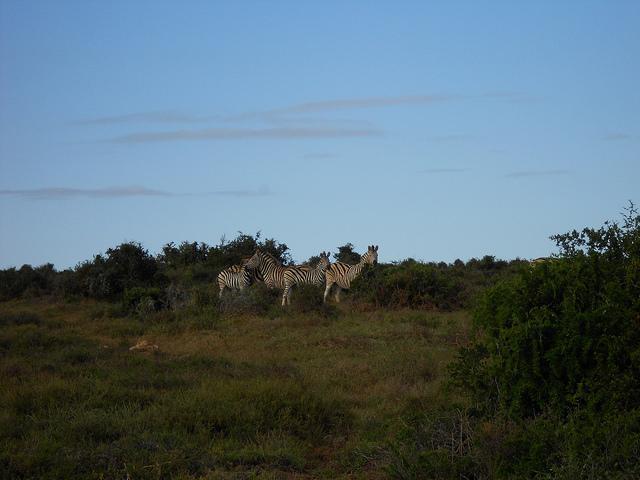How many types of animals are there?
Give a very brief answer. 1. How many roads are there?
Give a very brief answer. 0. How many cars are shown?
Give a very brief answer. 0. 